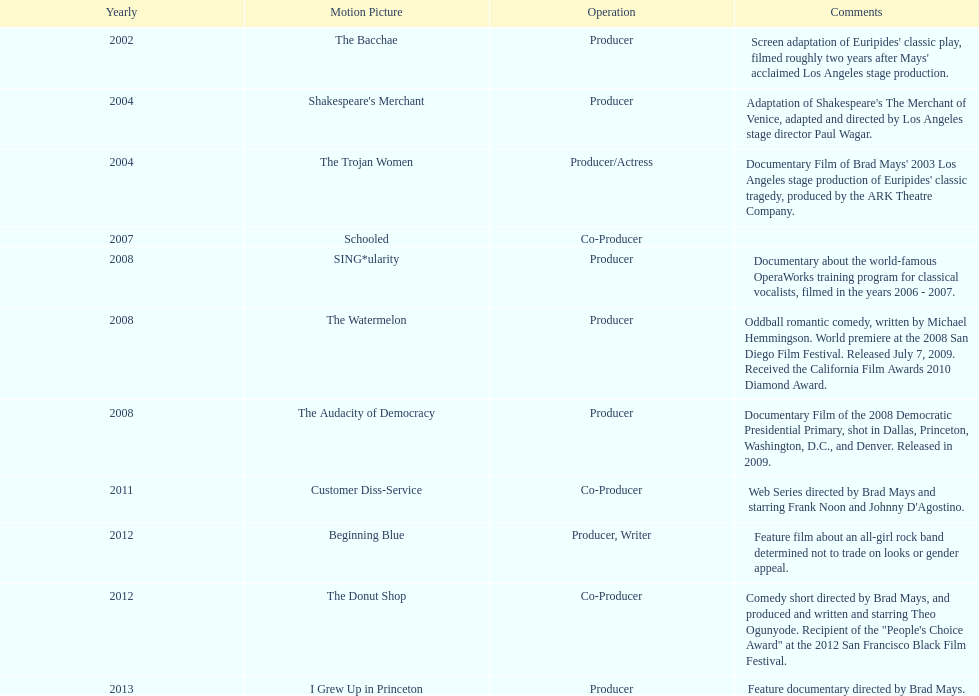Which year was there at least three movies? 2008. Could you help me parse every detail presented in this table? {'header': ['Yearly', 'Motion Picture', 'Operation', 'Comments'], 'rows': [['2002', 'The Bacchae', 'Producer', "Screen adaptation of Euripides' classic play, filmed roughly two years after Mays' acclaimed Los Angeles stage production."], ['2004', "Shakespeare's Merchant", 'Producer', "Adaptation of Shakespeare's The Merchant of Venice, adapted and directed by Los Angeles stage director Paul Wagar."], ['2004', 'The Trojan Women', 'Producer/Actress', "Documentary Film of Brad Mays' 2003 Los Angeles stage production of Euripides' classic tragedy, produced by the ARK Theatre Company."], ['2007', 'Schooled', 'Co-Producer', ''], ['2008', 'SING*ularity', 'Producer', 'Documentary about the world-famous OperaWorks training program for classical vocalists, filmed in the years 2006 - 2007.'], ['2008', 'The Watermelon', 'Producer', 'Oddball romantic comedy, written by Michael Hemmingson. World premiere at the 2008 San Diego Film Festival. Released July 7, 2009. Received the California Film Awards 2010 Diamond Award.'], ['2008', 'The Audacity of Democracy', 'Producer', 'Documentary Film of the 2008 Democratic Presidential Primary, shot in Dallas, Princeton, Washington, D.C., and Denver. Released in 2009.'], ['2011', 'Customer Diss-Service', 'Co-Producer', "Web Series directed by Brad Mays and starring Frank Noon and Johnny D'Agostino."], ['2012', 'Beginning Blue', 'Producer, Writer', 'Feature film about an all-girl rock band determined not to trade on looks or gender appeal.'], ['2012', 'The Donut Shop', 'Co-Producer', 'Comedy short directed by Brad Mays, and produced and written and starring Theo Ogunyode. Recipient of the "People\'s Choice Award" at the 2012 San Francisco Black Film Festival.'], ['2013', 'I Grew Up in Princeton', 'Producer', 'Feature documentary directed by Brad Mays.']]} 